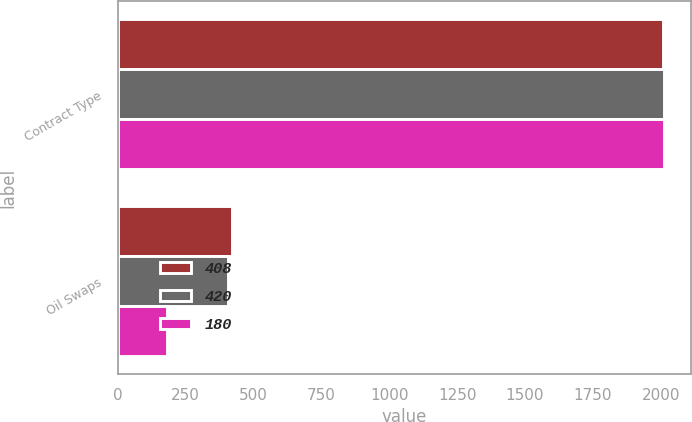Convert chart to OTSL. <chart><loc_0><loc_0><loc_500><loc_500><stacked_bar_chart><ecel><fcel>Contract Type<fcel>Oil Swaps<nl><fcel>408<fcel>2010<fcel>420<nl><fcel>420<fcel>2011<fcel>408<nl><fcel>180<fcel>2012<fcel>180<nl></chart> 